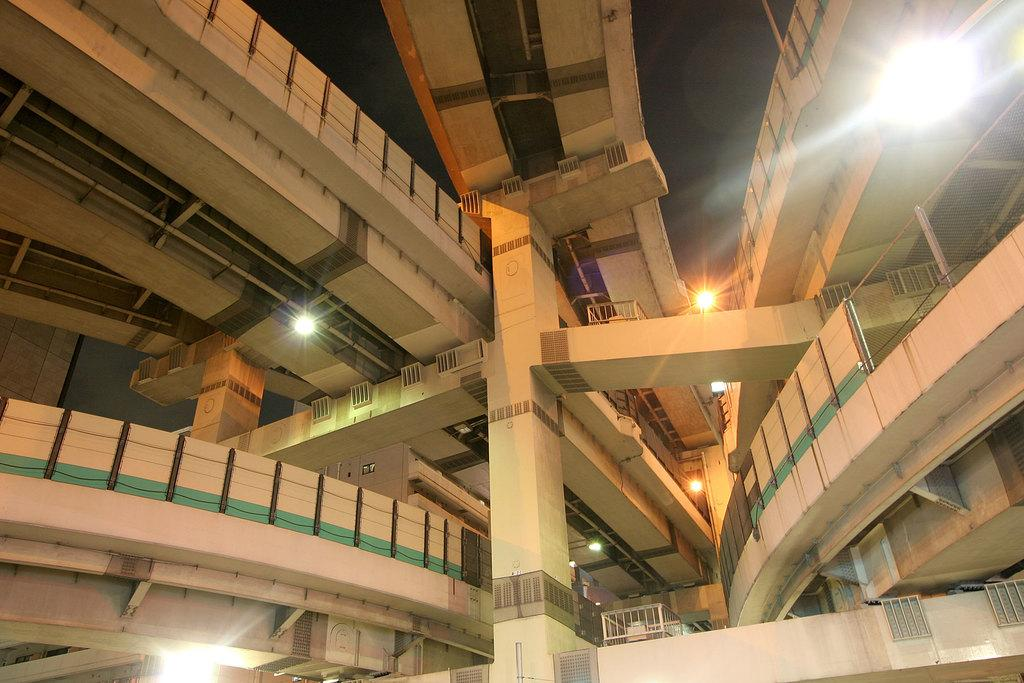What type of structure is present in the image? There is a building in the image. Can you describe any other elements in the image? Yes, there are lights visible in the image. How many ants can be seen carrying oranges in the image? There are no ants or oranges present in the image. What type of play is happening in the image? There is no play or any indication of play in the image. 